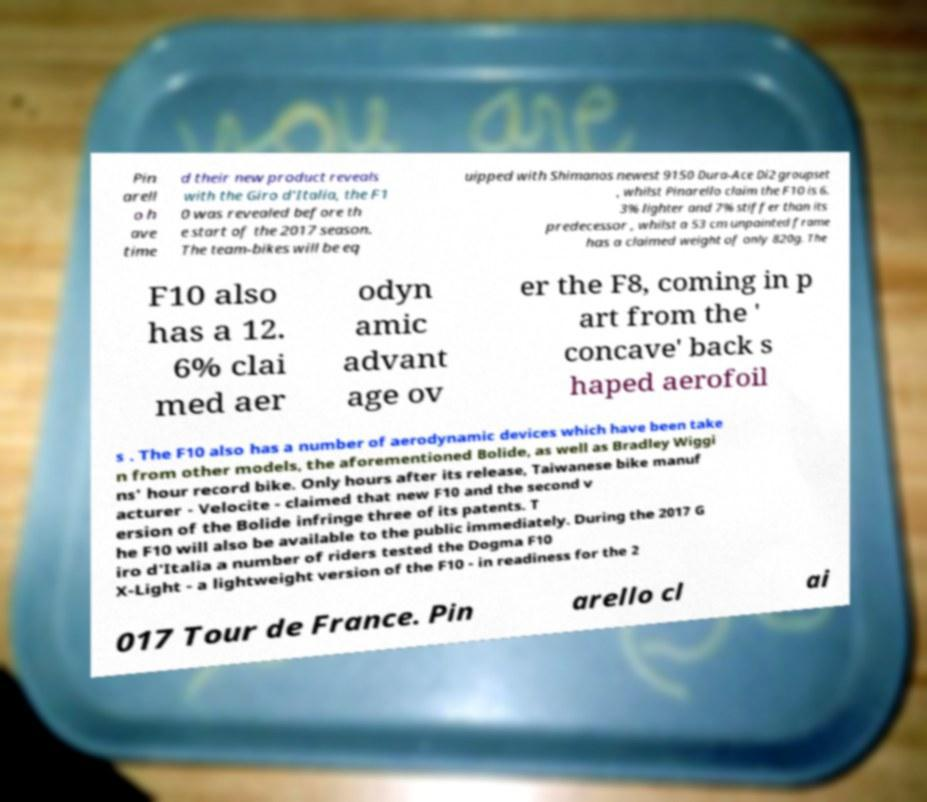For documentation purposes, I need the text within this image transcribed. Could you provide that? Pin arell o h ave time d their new product reveals with the Giro d'Italia, the F1 0 was revealed before th e start of the 2017 season. The team-bikes will be eq uipped with Shimanos newest 9150 Dura-Ace Di2 groupset , whilst Pinarello claim the F10 is 6. 3% lighter and 7% stiffer than its predecessor , whilst a 53 cm unpainted frame has a claimed weight of only 820g. The F10 also has a 12. 6% clai med aer odyn amic advant age ov er the F8, coming in p art from the ' concave' back s haped aerofoil s . The F10 also has a number of aerodynamic devices which have been take n from other models, the aforementioned Bolide, as well as Bradley Wiggi ns' hour record bike. Only hours after its release, Taiwanese bike manuf acturer - Velocite - claimed that new F10 and the second v ersion of the Bolide infringe three of its patents. T he F10 will also be available to the public immediately. During the 2017 G iro d'Italia a number of riders tested the Dogma F10 X-Light - a lightweight version of the F10 - in readiness for the 2 017 Tour de France. Pin arello cl ai 